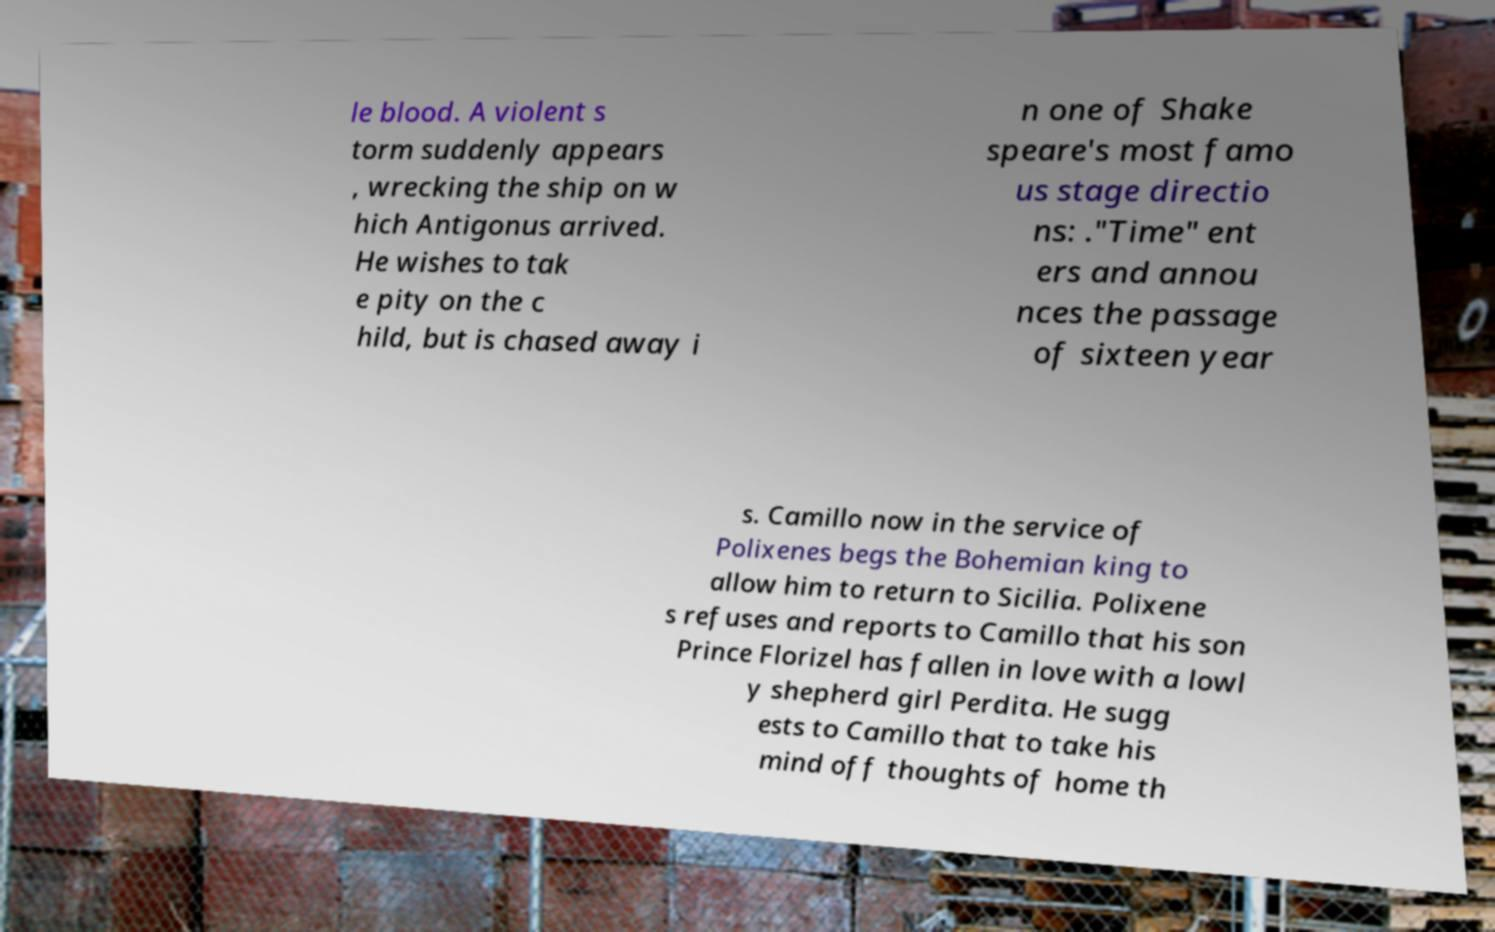I need the written content from this picture converted into text. Can you do that? le blood. A violent s torm suddenly appears , wrecking the ship on w hich Antigonus arrived. He wishes to tak e pity on the c hild, but is chased away i n one of Shake speare's most famo us stage directio ns: ."Time" ent ers and annou nces the passage of sixteen year s. Camillo now in the service of Polixenes begs the Bohemian king to allow him to return to Sicilia. Polixene s refuses and reports to Camillo that his son Prince Florizel has fallen in love with a lowl y shepherd girl Perdita. He sugg ests to Camillo that to take his mind off thoughts of home th 